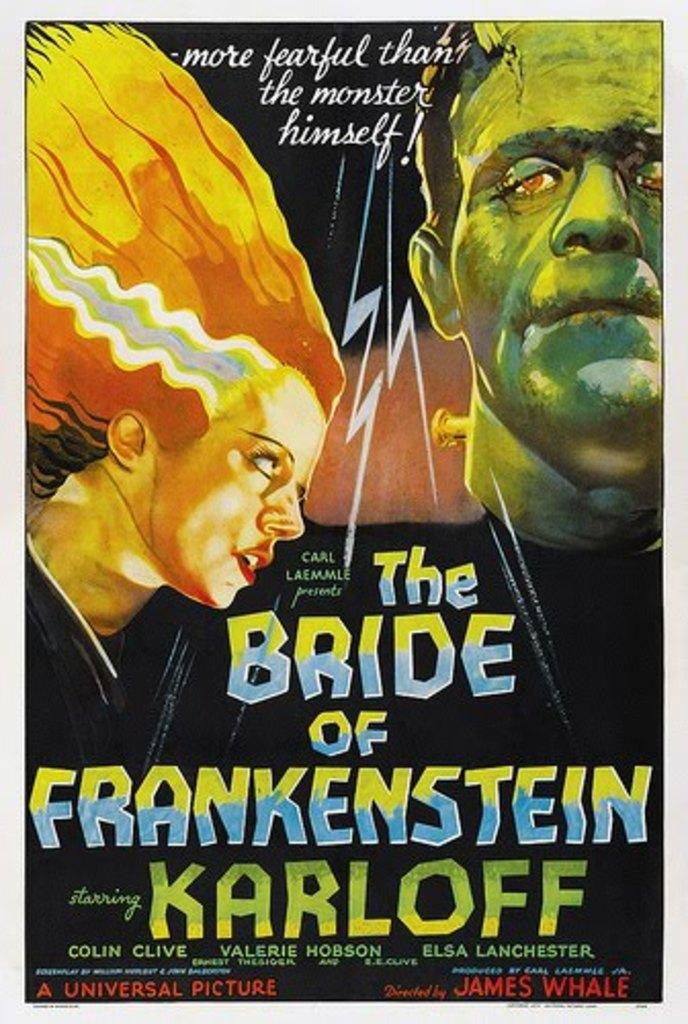What is present in the image that features visual content? There is a poster in the image. What type of images are on the poster? The poster contains animated pictures of a man and a woman. Is there any text on the poster? Yes, there is text written on the poster. What type of drain is visible on the poster? There is no drain present on the poster; it features animated pictures of a man and a woman, along with text. What kind of magic is being performed by the man and woman on the poster? There is no magic being performed by the man and woman on the poster; they are simply animated pictures. 